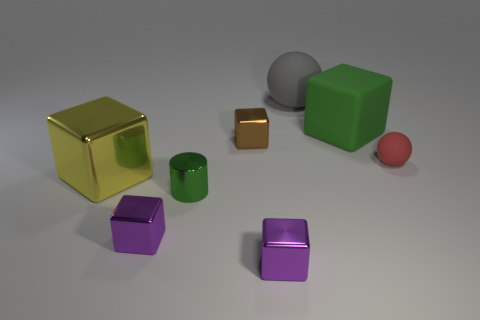What material is the thing behind the big green block that is right of the purple shiny object that is right of the tiny brown metallic block?
Your response must be concise. Rubber. Are there any things that have the same material as the small brown cube?
Make the answer very short. Yes. Is the material of the gray ball the same as the yellow object?
Offer a very short reply. No. How many cubes are metal things or big red metallic things?
Ensure brevity in your answer.  4. What color is the small thing that is the same material as the green cube?
Keep it short and to the point. Red. Are there fewer small blue rubber spheres than small red matte things?
Keep it short and to the point. Yes. There is a small thing that is right of the green rubber object; is its shape the same as the tiny shiny object behind the small rubber object?
Provide a succinct answer. No. What number of objects are either shiny blocks or big gray objects?
Ensure brevity in your answer.  5. What is the color of the ball that is the same size as the yellow shiny block?
Your answer should be compact. Gray. There is a large block in front of the tiny brown cube; how many large shiny blocks are to the right of it?
Provide a short and direct response. 0. 